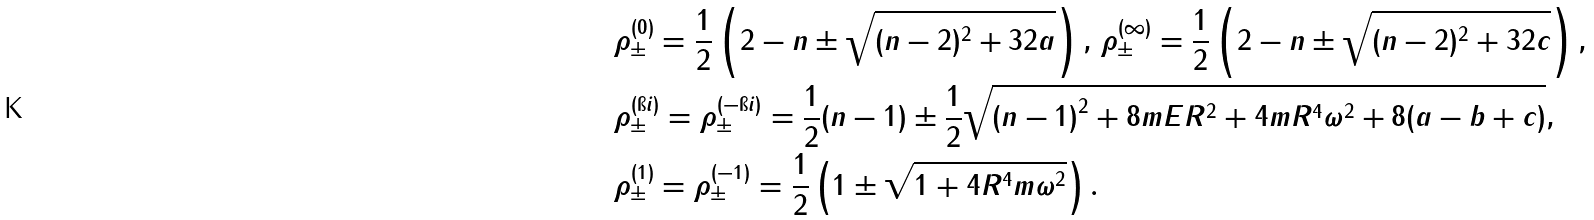<formula> <loc_0><loc_0><loc_500><loc_500>& \rho ^ { ( 0 ) } _ { \pm } = \frac { 1 } { 2 } \left ( 2 - n \pm \sqrt { ( n - 2 ) ^ { 2 } + 3 2 a } \right ) , \, \rho ^ { ( \infty ) } _ { \pm } = \frac { 1 } { 2 } \left ( 2 - n \pm \sqrt { ( n - 2 ) ^ { 2 } + 3 2 c } \right ) , \\ & \rho ^ { ( \i i ) } _ { \pm } = \rho ^ { ( - \i i ) } _ { \pm } = \frac { 1 } { 2 } ( n - 1 ) \pm \frac { 1 } { 2 } \sqrt { \left ( n - 1 \right ) ^ { 2 } + 8 m E R ^ { 2 } + 4 m R ^ { 4 } \omega ^ { 2 } + 8 ( a - b + c ) } , \\ & \rho ^ { ( 1 ) } _ { \pm } = \rho ^ { ( - 1 ) } _ { \pm } = \frac { 1 } { 2 } \left ( 1 \pm \sqrt { 1 + 4 R ^ { 4 } m \omega ^ { 2 } } \right ) .</formula> 